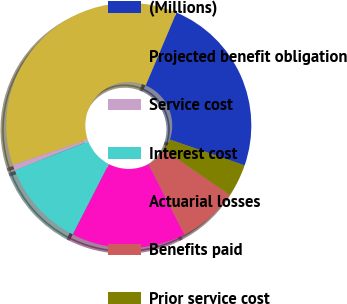Convert chart to OTSL. <chart><loc_0><loc_0><loc_500><loc_500><pie_chart><fcel>(Millions)<fcel>Projected benefit obligation<fcel>Service cost<fcel>Interest cost<fcel>Actuarial losses<fcel>Benefits paid<fcel>Prior service cost<nl><fcel>23.92%<fcel>36.61%<fcel>0.72%<fcel>11.48%<fcel>15.07%<fcel>7.89%<fcel>4.31%<nl></chart> 